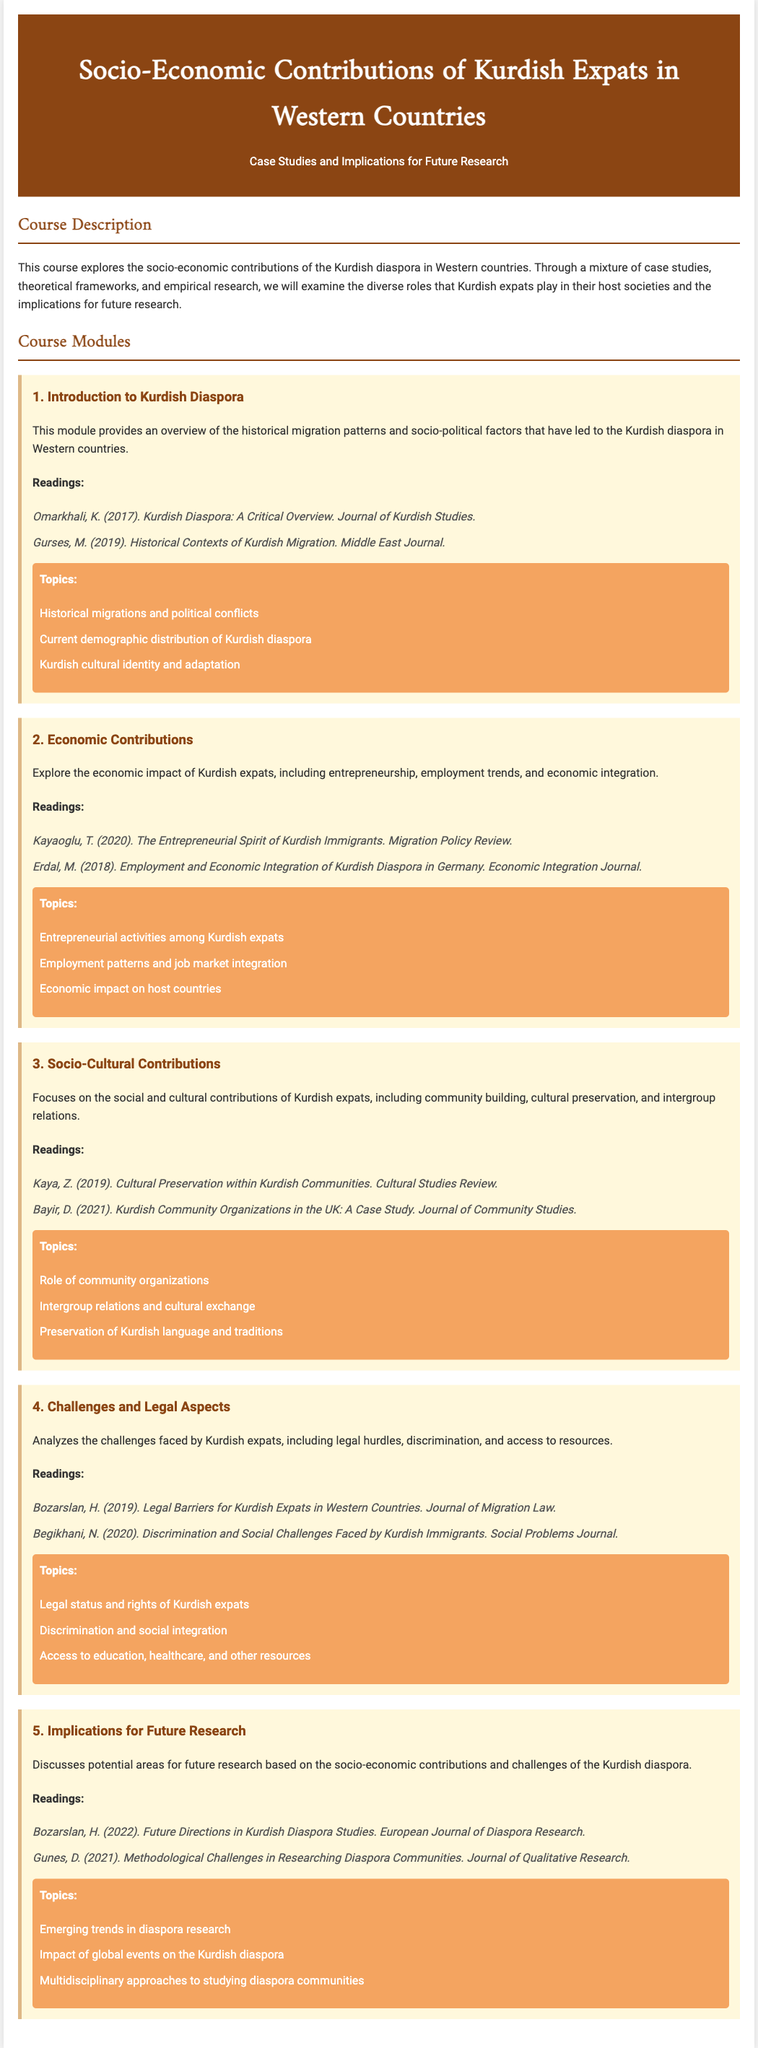what is the title of the course? The title can be found at the top of the syllabus, which focuses on the contributions of Kurdish expats.
Answer: Socio-Economic Contributions of Kurdish Expats in Western Countries how many modules are in the course? The total number of modules is listed in the course modules section.
Answer: 5 who wrote "Future Directions in Kurdish Diaspora Studies"? This is a reading listed in the fifth module, which identifies the author.
Answer: Bozarslan what is the focus of the second module? The description in the second module outlines its main subject matter related to the Kurdish diaspora.
Answer: Economic Contributions what topic is covered in the third module? The topics section under the third module lists the subjects being discussed.
Answer: Role of community organizations what year was "Kurdish Diaspora: A Critical Overview" published? The year of publication is mentioned in the reading reference in the first module.
Answer: 2017 which module discusses legal challenges for Kurdish expats? The module number and title indicate which module addresses this specific issue.
Answer: 4. Challenges and Legal Aspects what is a key subject in the fifth module regarding future research? The topics listed in the fifth module indicate emerging trends related to research priorities.
Answer: Emerging trends in diaspora research 